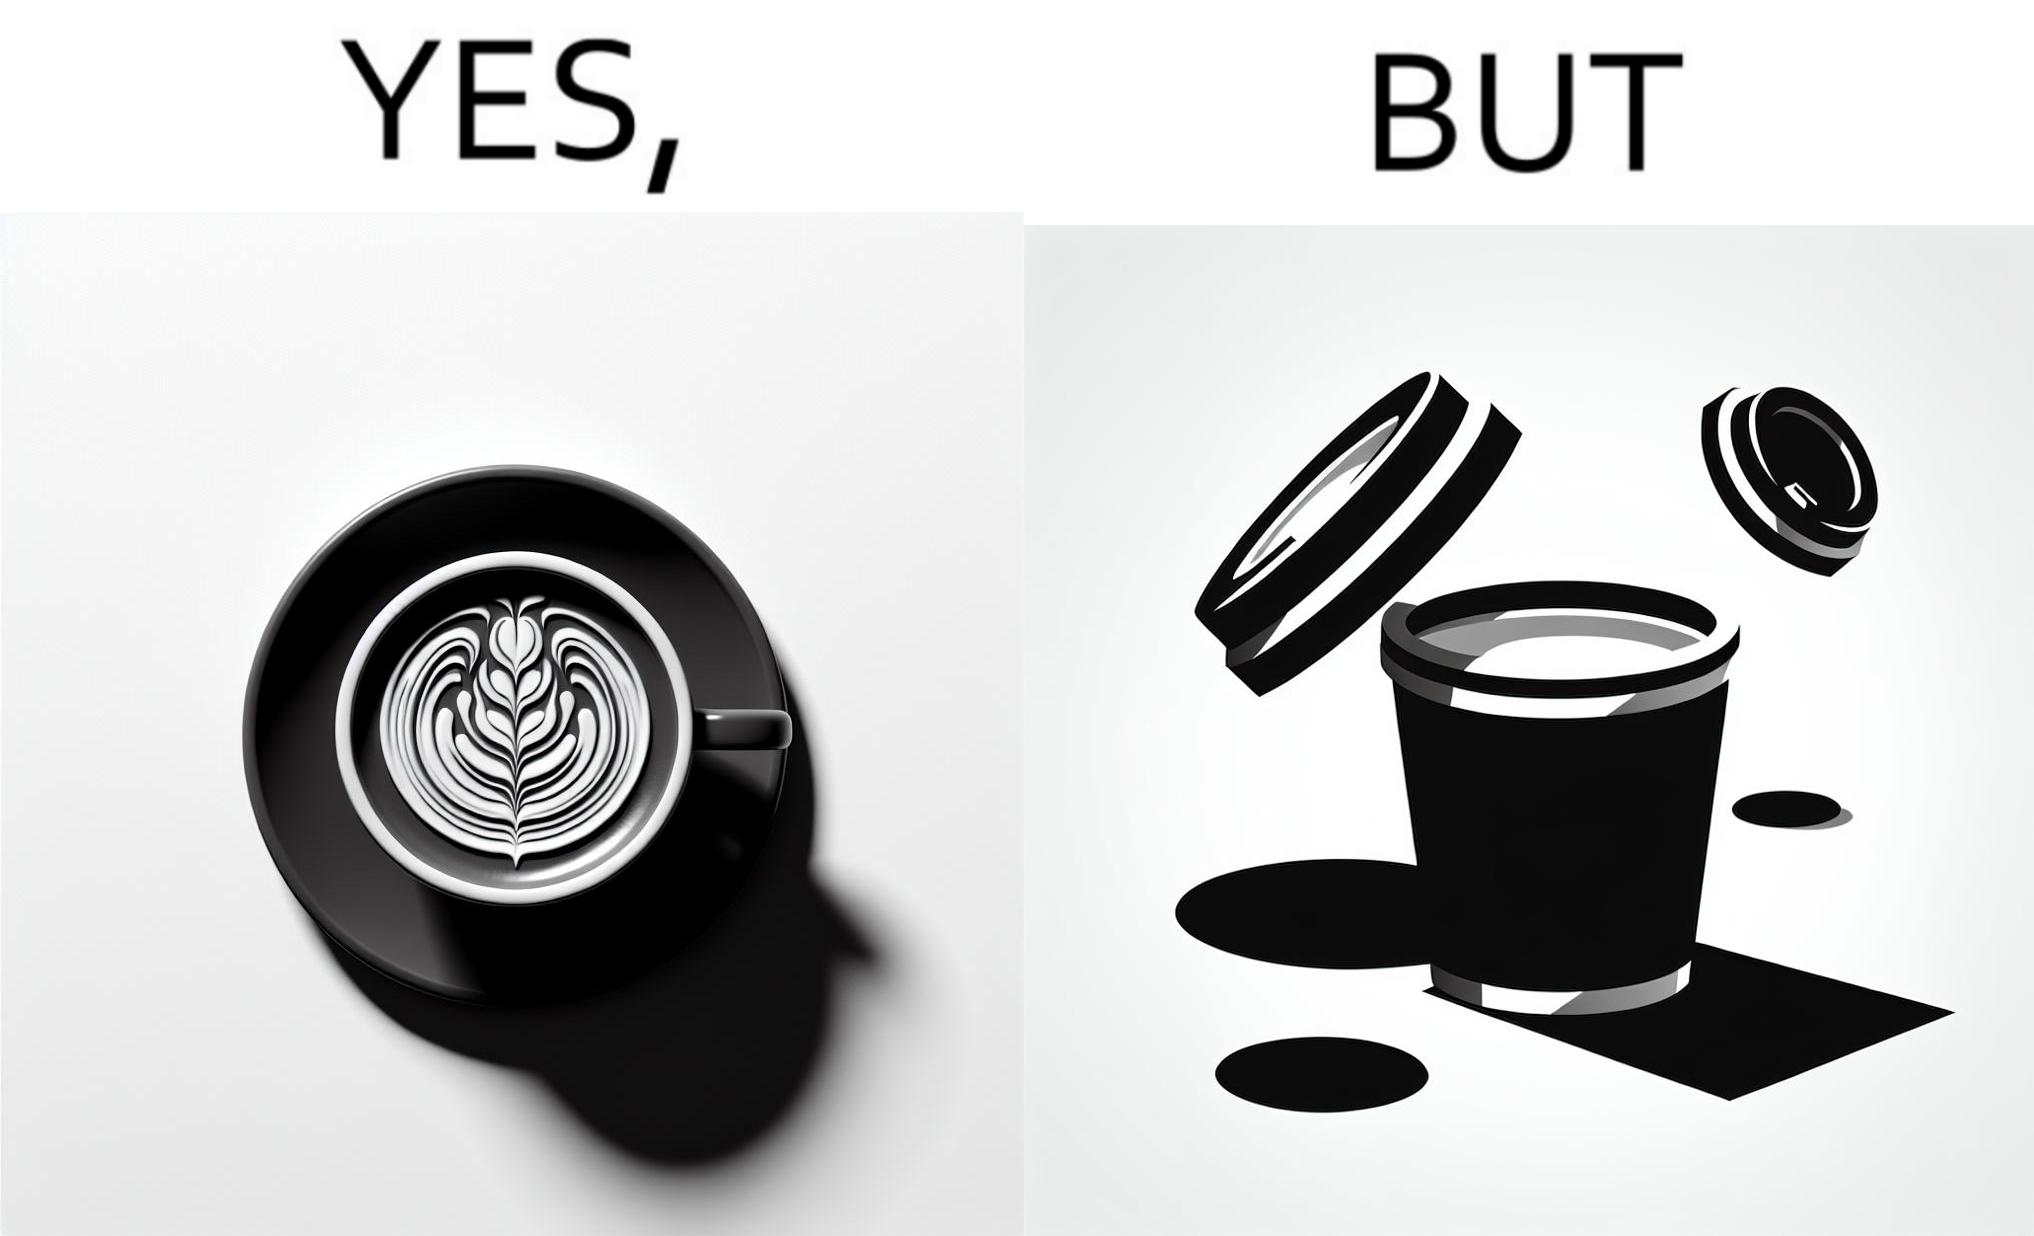What does this image depict? The images are funny since it shows how someone has put effort into a cup of coffee to do latte art on it only for it to be invisible after a lid is put on the coffee cup before serving to a customer 